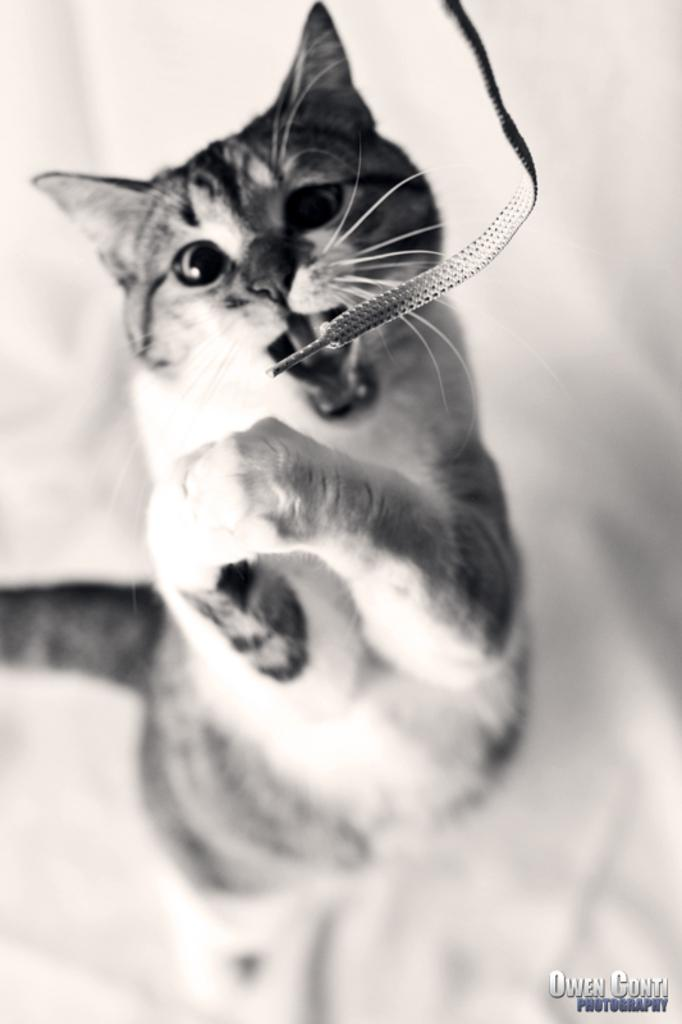What is the color scheme of the image? The image is black and white. What animal can be seen in the image? There is a cat in the image. What object is laying on the ground in the image? There is a shoe laying in the image. Where is the text located in the image? The text is at the bottom of the image. What type of drain is visible in the image? There is no drain present in the image. What is the cat using its tongue for in the image? The cat is not using its tongue for anything in the image, as it is a still image and not a video. 